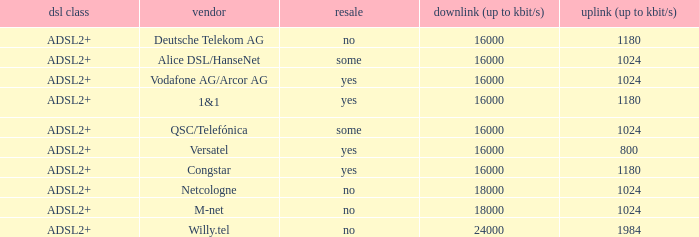Parse the table in full. {'header': ['dsl class', 'vendor', 'resale', 'downlink (up to kbit/s)', 'uplink (up to kbit/s)'], 'rows': [['ADSL2+', 'Deutsche Telekom AG', 'no', '16000', '1180'], ['ADSL2+', 'Alice DSL/HanseNet', 'some', '16000', '1024'], ['ADSL2+', 'Vodafone AG/Arcor AG', 'yes', '16000', '1024'], ['ADSL2+', '1&1', 'yes', '16000', '1180'], ['ADSL2+', 'QSC/Telefónica', 'some', '16000', '1024'], ['ADSL2+', 'Versatel', 'yes', '16000', '800'], ['ADSL2+', 'Congstar', 'yes', '16000', '1180'], ['ADSL2+', 'Netcologne', 'no', '18000', '1024'], ['ADSL2+', 'M-net', 'no', '18000', '1024'], ['ADSL2+', 'Willy.tel', 'no', '24000', '1984']]} What is the resale category for the provider NetCologne? No. 